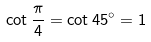Convert formula to latex. <formula><loc_0><loc_0><loc_500><loc_500>\cot { \frac { \pi } { 4 } } = \cot 4 5 ^ { \circ } = 1</formula> 